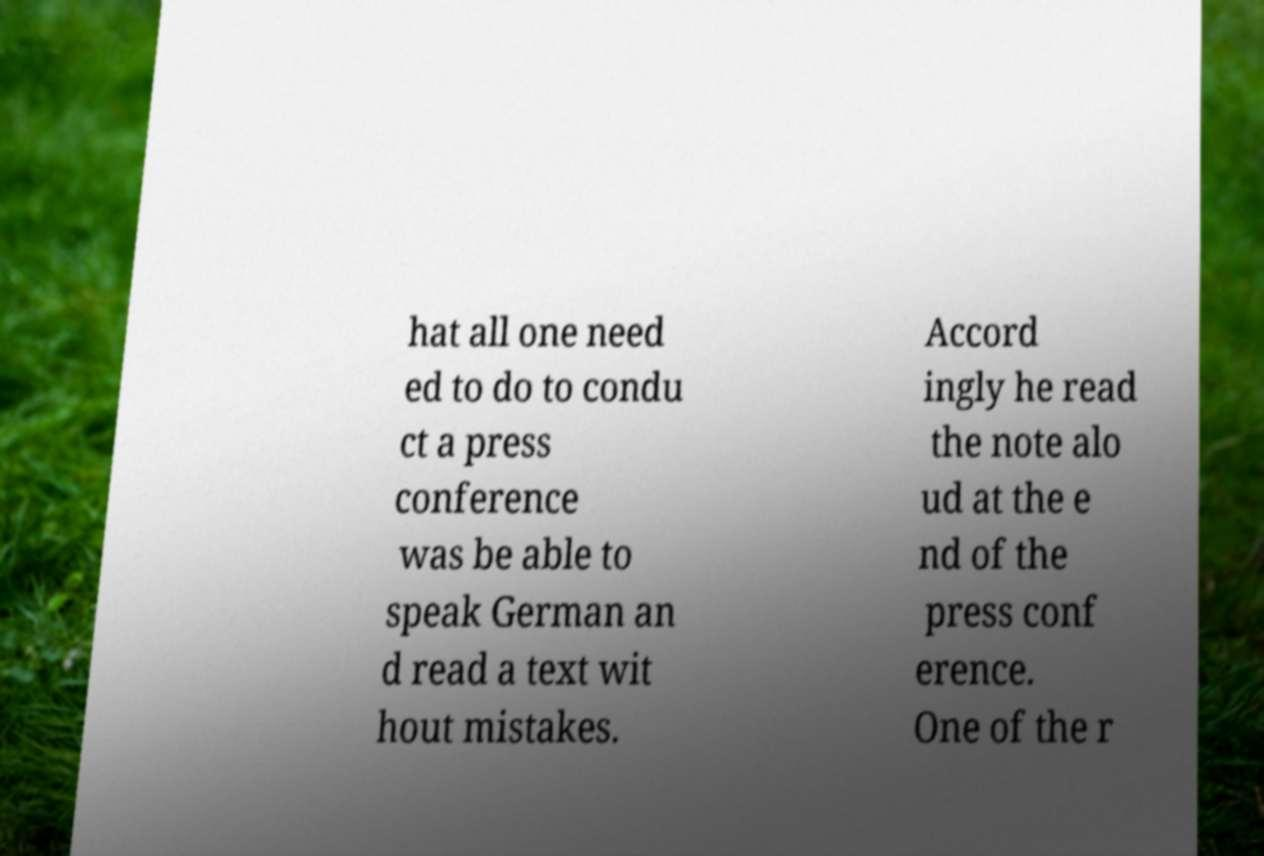Can you accurately transcribe the text from the provided image for me? hat all one need ed to do to condu ct a press conference was be able to speak German an d read a text wit hout mistakes. Accord ingly he read the note alo ud at the e nd of the press conf erence. One of the r 